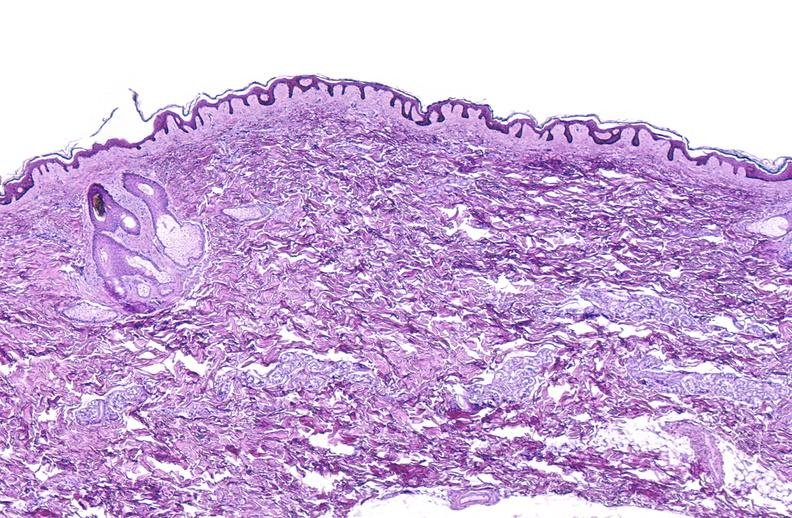where is this?
Answer the question using a single word or phrase. Skin 